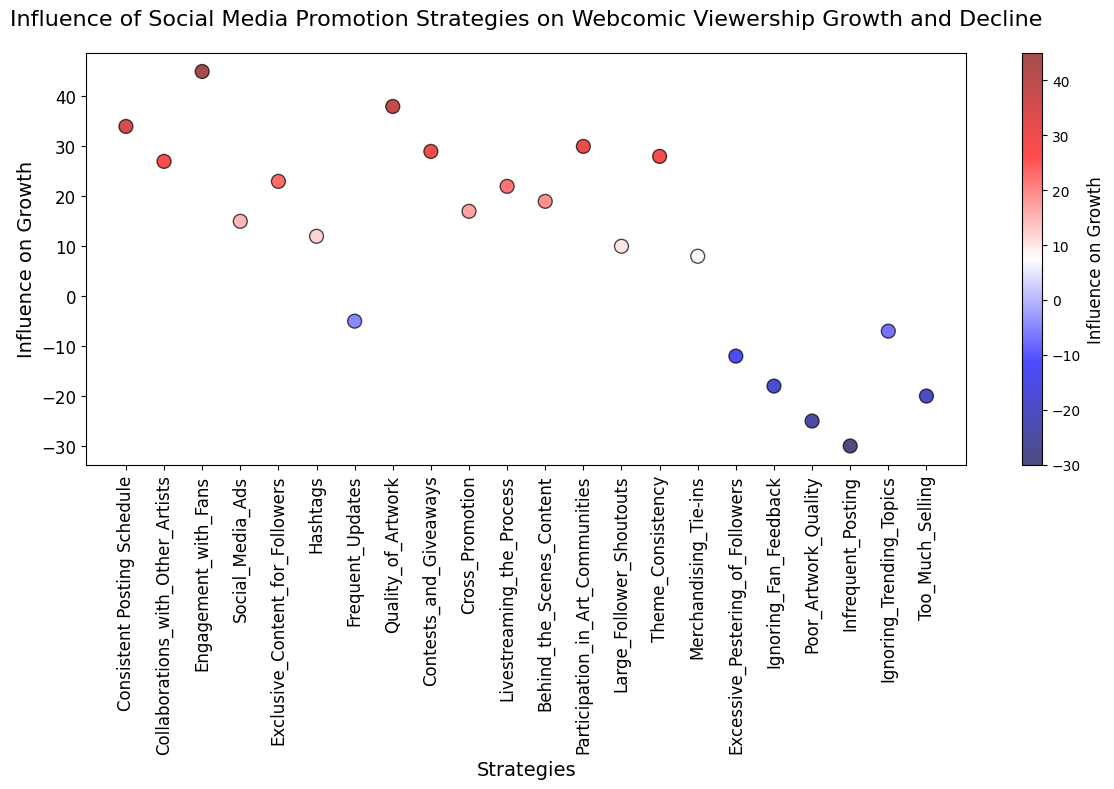What strategy has the highest influence on growth? Referring to the y-axis and data points, "Engagement with Fans" has the highest value at 45.
Answer: Engagement with Fans What is the combined influence on growth of "Collaborations with Other Artists" and "Participation in Art Communities"? The influence on growth for "Collaborations with Other Artists" is 27, and for "Participation in Art Communities" is 30. Adding them gives 27 + 30 = 57.
Answer: 57 Which strategy has a more positive influence on growth, "Quality of Artwork" or "Consistent Posting Schedule"? The data point for "Quality of Artwork" is at 38, and "Consistent Posting Schedule" is at 34. Since 38 is greater than 34, "Quality of Artwork" has a more positive influence on growth.
Answer: Quality of Artwork How many strategies have a negative influence on growth? Referring to the y-axis, count the data points that fall below zero: "Frequent Updates" (-5), "Excessive Pestering of Followers" (-12), "Ignoring Fan Feedback" (-18), "Poor Artwork Quality" (-25), "Infrequent Posting" (-30), and "Too Much Selling" (-20). There are 6 such strategies.
Answer: 6 What is the difference in influence on growth between "Livestreaming the Process" and "Ignoring Trending Topics"? "Livestreaming the Process" has an influence of 22, and "Ignoring Trending Topics" has -7. The difference is 22 - (-7) = 29.
Answer: 29 Which has a higher influence on growth, "Merchandising Tie-ins" or "Large Follower Shoutouts"? The influence of "Merchandising Tie-ins" is 8, and "Large Follower Shoutouts" is 10. Since 10 is greater than 8, "Large Follower Shoutouts" has a higher influence on growth.
Answer: Large Follower Shoutouts Which strategies fall within the influence range of 20 to 30? Check data points where influence values are between 20 and 30: "Exclusive Content for Followers" (23), "Contests and Giveaways" (29), "Livestreaming the Process" (22), "Behind the Scenes Content" (19 is close but doesn't qualify), "Participation in Art Communities" (30), and "Theme Consistency" (28). Thus, the strategies are "Exclusive Content for Followers," "Contests and Giveaways," "Livestreaming the Process," "Participation in Art Communities," and "Theme Consistency."
Answer: Exclusive Content for Followers, Contests and Giveaways, Livestreaming the Process, Participation in Art Communities, Theme Consistency Which strategy has the least influence on growth? By observing the lowest point on the y-axis, "Infrequent Posting" has the least influence at -30.
Answer: Infrequent Posting Is the influence on growth of "Hashtags" greater or lesser than that of "Social Media Ads"? The influence value of "Hashtags" is 12, and "Social Media Ads" is 15. Since 12 is less than 15, "Hashtags" has a lesser influence on growth.
Answer: Lesser 